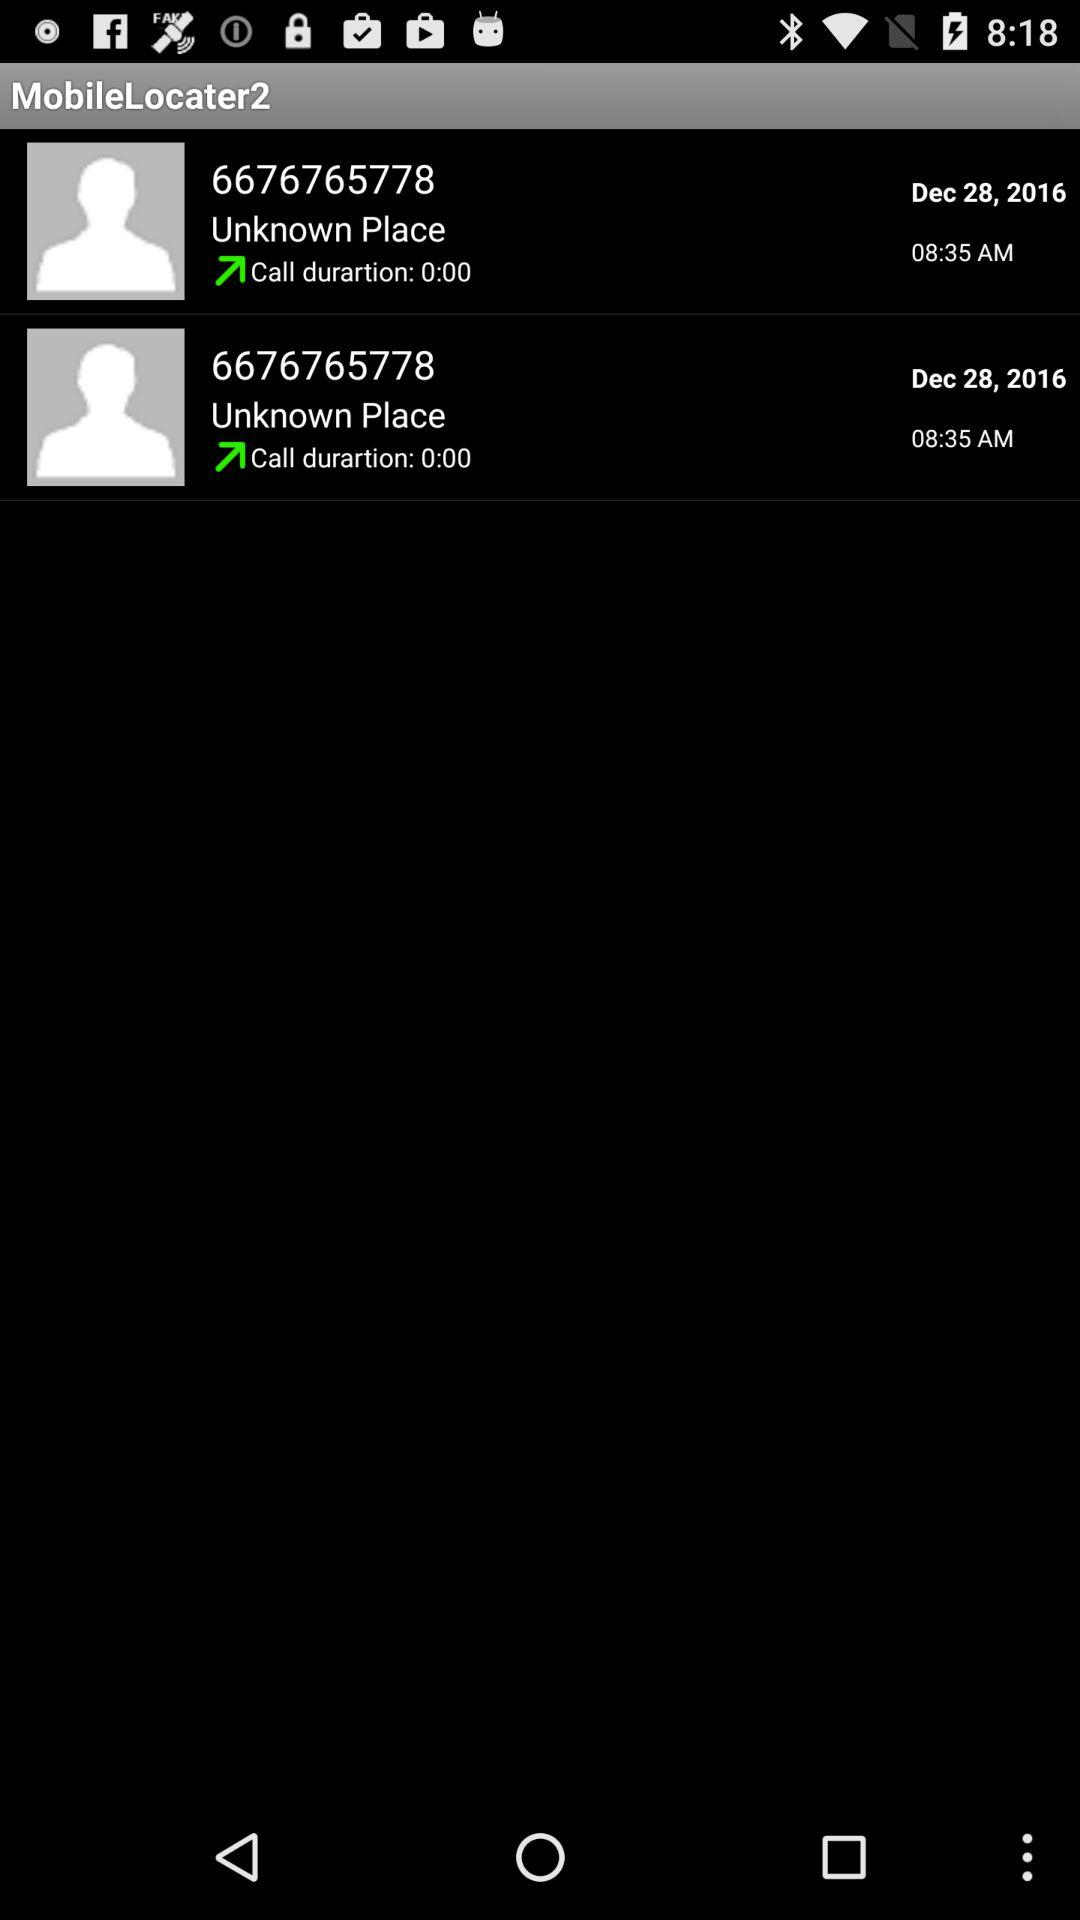What was the call duration of 6676765778? The call duration of 6676765778 is 0 minutes. 